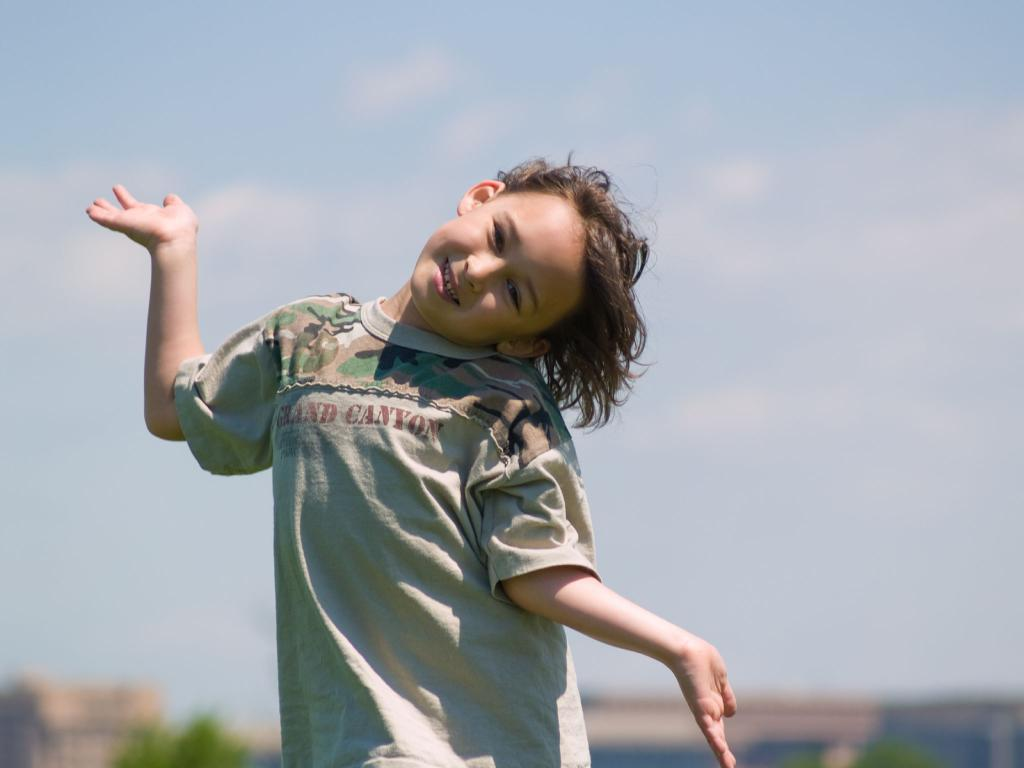Who is the main subject in the image? There is a child present in the image. What can be observed about the background of the image? The background of the image is blurred. What type of oil can be seen dripping from the child's hair in the image? There is no oil present in the image, nor is there any indication of dripping oil from the child's hair. 